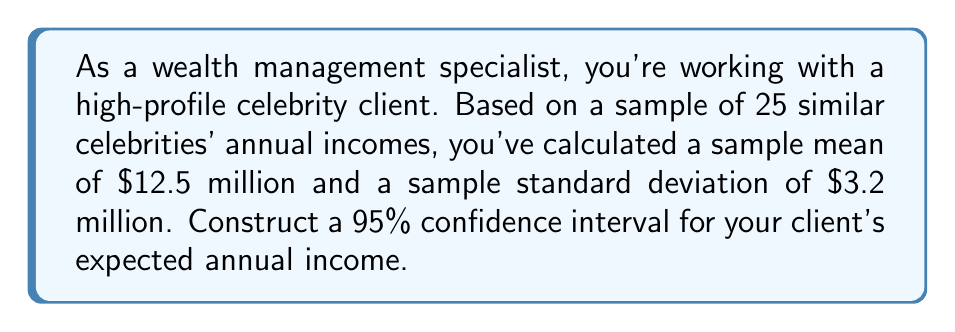Provide a solution to this math problem. To construct a 95% confidence interval, we'll follow these steps:

1) The formula for a confidence interval is:

   $$\bar{x} \pm t_{\alpha/2} \cdot \frac{s}{\sqrt{n}}$$

   where $\bar{x}$ is the sample mean, $s$ is the sample standard deviation, $n$ is the sample size, and $t_{\alpha/2}$ is the t-value for a 95% confidence level with $n-1$ degrees of freedom.

2) We have:
   $\bar{x} = 12.5$ million
   $s = 3.2$ million
   $n = 25$

3) For a 95% confidence interval with 24 degrees of freedom (n-1), the t-value is approximately 2.064.

4) Plugging these values into our formula:

   $$12.5 \pm 2.064 \cdot \frac{3.2}{\sqrt{25}}$$

5) Simplify:
   $$12.5 \pm 2.064 \cdot \frac{3.2}{5} = 12.5 \pm 2.064 \cdot 0.64 = 12.5 \pm 1.32$$

6) Therefore, the confidence interval is:

   $$(12.5 - 1.32, 12.5 + 1.32) = (11.18, 13.82)$$

This means we can be 95% confident that the true population mean annual income for celebrities like your client falls between $11.18 million and $13.82 million.
Answer: ($11.18 million, $13.82 million) 